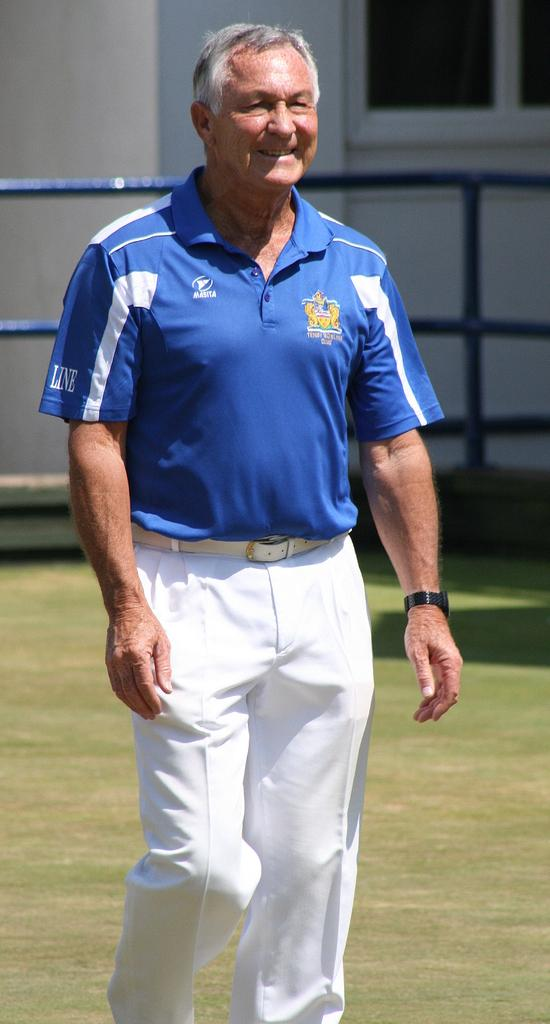What is the main subject in the center of the image? There is a man standing in the center of the image. What can be seen in the background of the image? There is a window, a wall, and rods in the background of the image. What is visible at the bottom of the image? The ground is visible at the bottom of the image. What type of lead is the man holding in the image? There is no lead present in the image; the man is not holding anything. What type of office can be seen in the background of the image? There is no office visible in the image; only a window, wall, and rods are present in the background. 